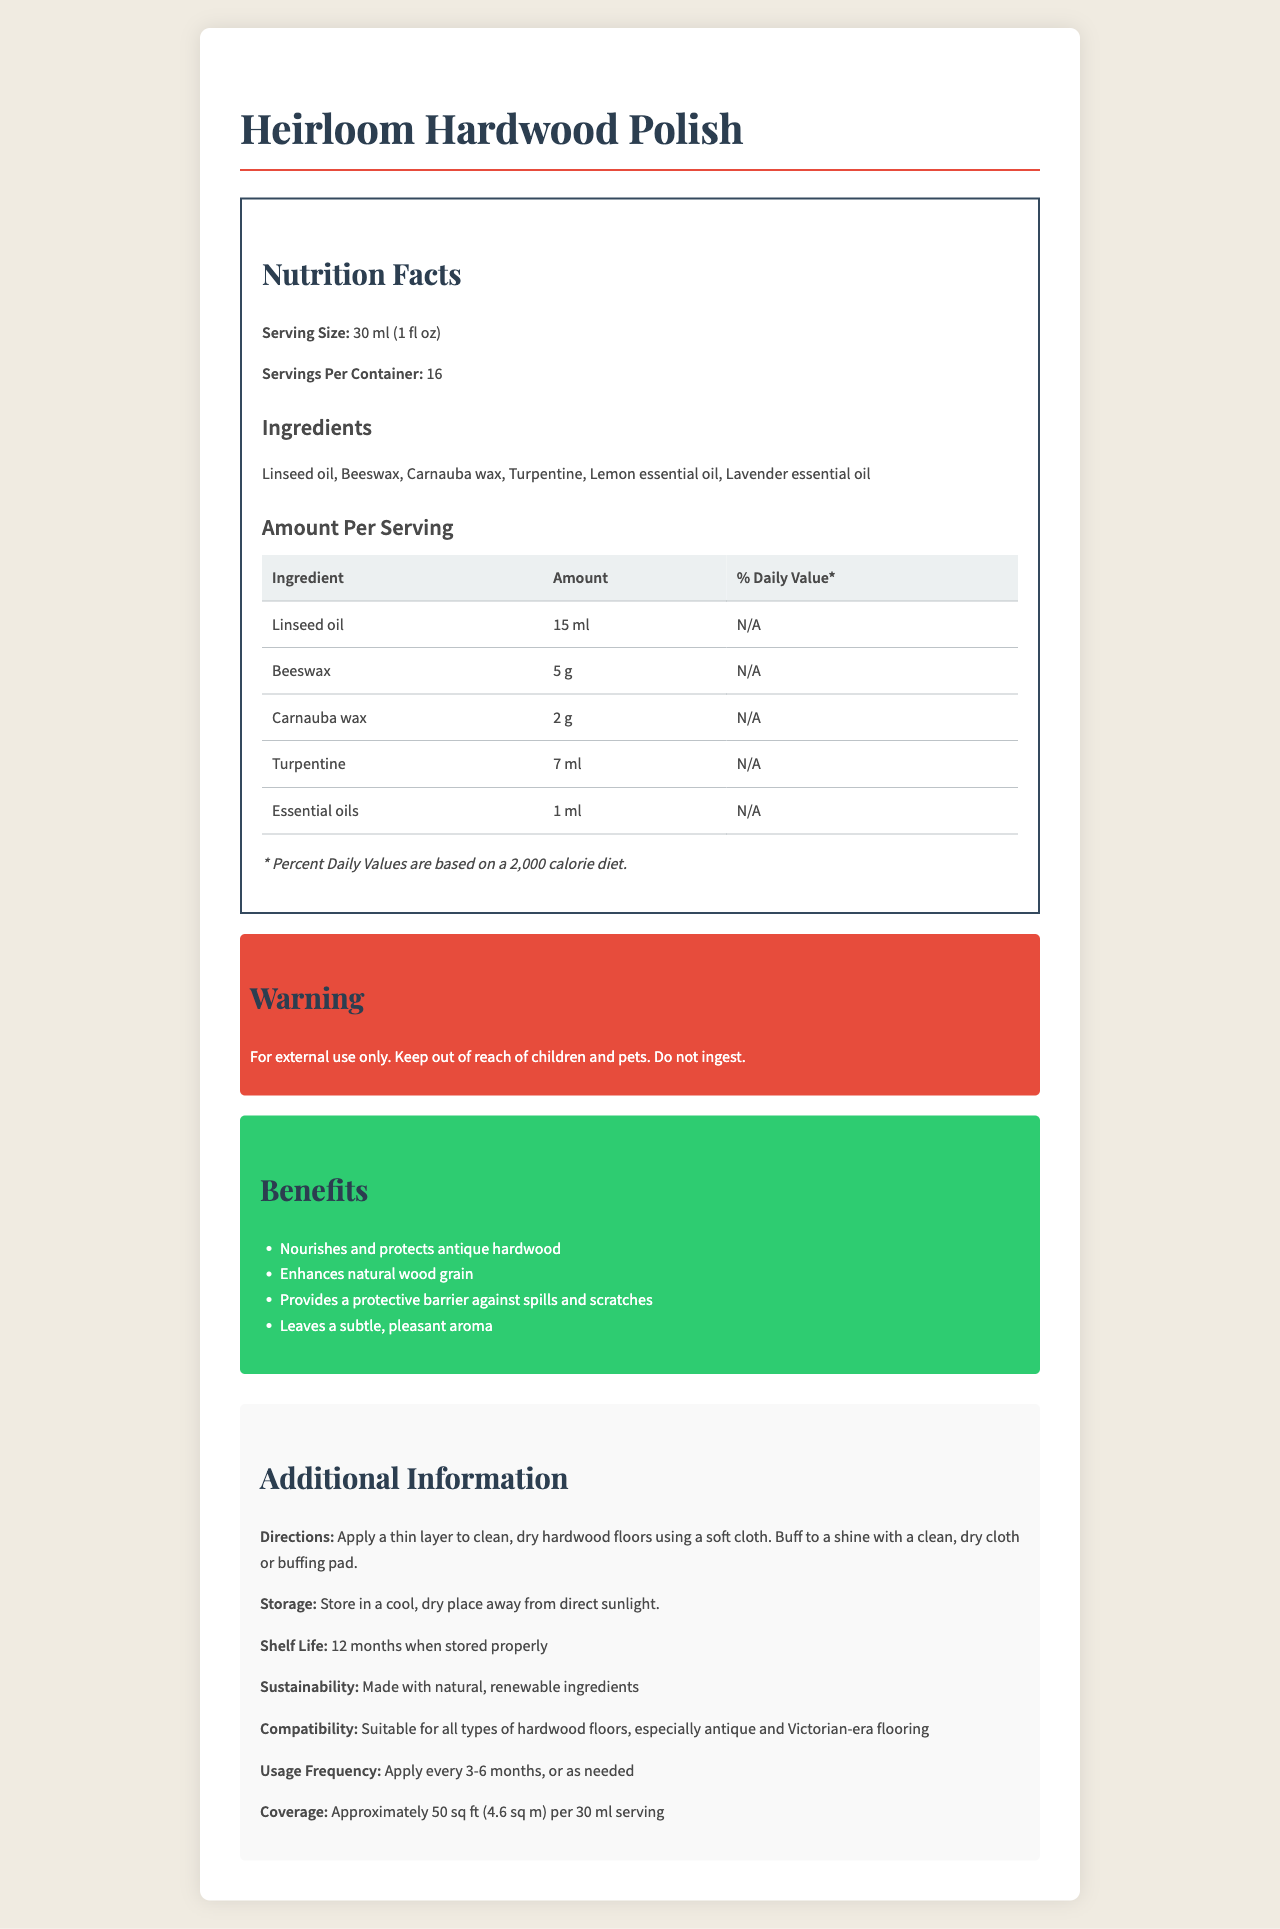what is the serving size? The serving size is specifically mentioned under "Nutrition Facts" as 30 ml (1 fl oz).
Answer: 30 ml (1 fl oz) How many servings are there per container? The number of servings per container is mentioned as 16 in the "Nutrition Facts" section.
Answer: 16 What are the main ingredients in the Heirloom Hardwood Polish? These ingredients are listed under "Ingredients."
Answer: Linseed oil, Beeswax, Carnauba wax, Turpentine, Lemon essential oil, Lavender essential oil What is the primary application method for Heirloom Hardwood Polish? The directions specify this method for application.
Answer: Apply a thin layer to clean, dry hardwood floors using a soft cloth. Buff to a shine with a clean, dry cloth or buffing pad. What is the shelf life of Heirloom Hardwood Polish? This information is provided under "Additional Information."
Answer: 12 months when stored properly Which ingredient is used the most in one serving of Heirloom Hardwood Polish? A. Beeswax B. Linseed oil C. Carnauba wax D. Turpentine The "Amount Per Serving" table shows that Linseed oil (15 ml) is the most used ingredient in a serving size.
Answer: B. Linseed oil What benefit does the Heirloom Hardwood Polish provide specifically related to the appearance of the wood? A. Provides a protective barrier B. Enhances natural wood grain C. Leaves a pleasant aroma D. Prevents color fading One of the benefits listed is "Enhances natural wood grain," directly related to the appearance of the wood.
Answer: B. Enhances natural wood grain Is the Heirloom Hardwood Polish safe for ingestion? The warning section clearly states "Do not ingest."
Answer: No What type of aroma does the Heirloom Hardwood Polish leave? The benefits section mentions that it leaves a subtle, pleasant aroma.
Answer: Leaves a subtle, pleasant aroma How often should one apply Heirloom Hardwood Polish? The usage frequency section suggests applying it every 3-6 months or as needed.
Answer: Apply every 3-6 months, or as needed Summarize the main purpose and benefits of Heirloom Hardwood Polish. This summary covers the product's main purpose and key benefits mentioned in the document.
Answer: Heirloom Hardwood Polish is a specially formulated product for nourishing and protecting antique hardwood floors. It enhances the natural wood grain, provides a protective barrier against spills and scratches, and leaves a subtle, pleasant aroma. It contains natural and renewable ingredients, ensuring sustainability. Is it stated how much coverage one serving of the polish provides? The coverage section states that one 30 ml serving covers approximately 50 sq ft (4.6 sq m).
Answer: Yes Can Heirloom Hardwood Polish be used on non-hardwood floors? The document only mentions its suitability for all types of hardwood floors, especially antique and Victorian-era flooring, but does not provide information on non-hardwood floors use.
Answer: Not enough information What should be done to achieve the best results when using Heirloom Hardwood Polish? The directions specify the steps needed to achieve the best results.
Answer: Apply a thin layer to clean, dry hardwood floors using a soft cloth. Buff to a shine with a clean, dry cloth or buffing pad. 